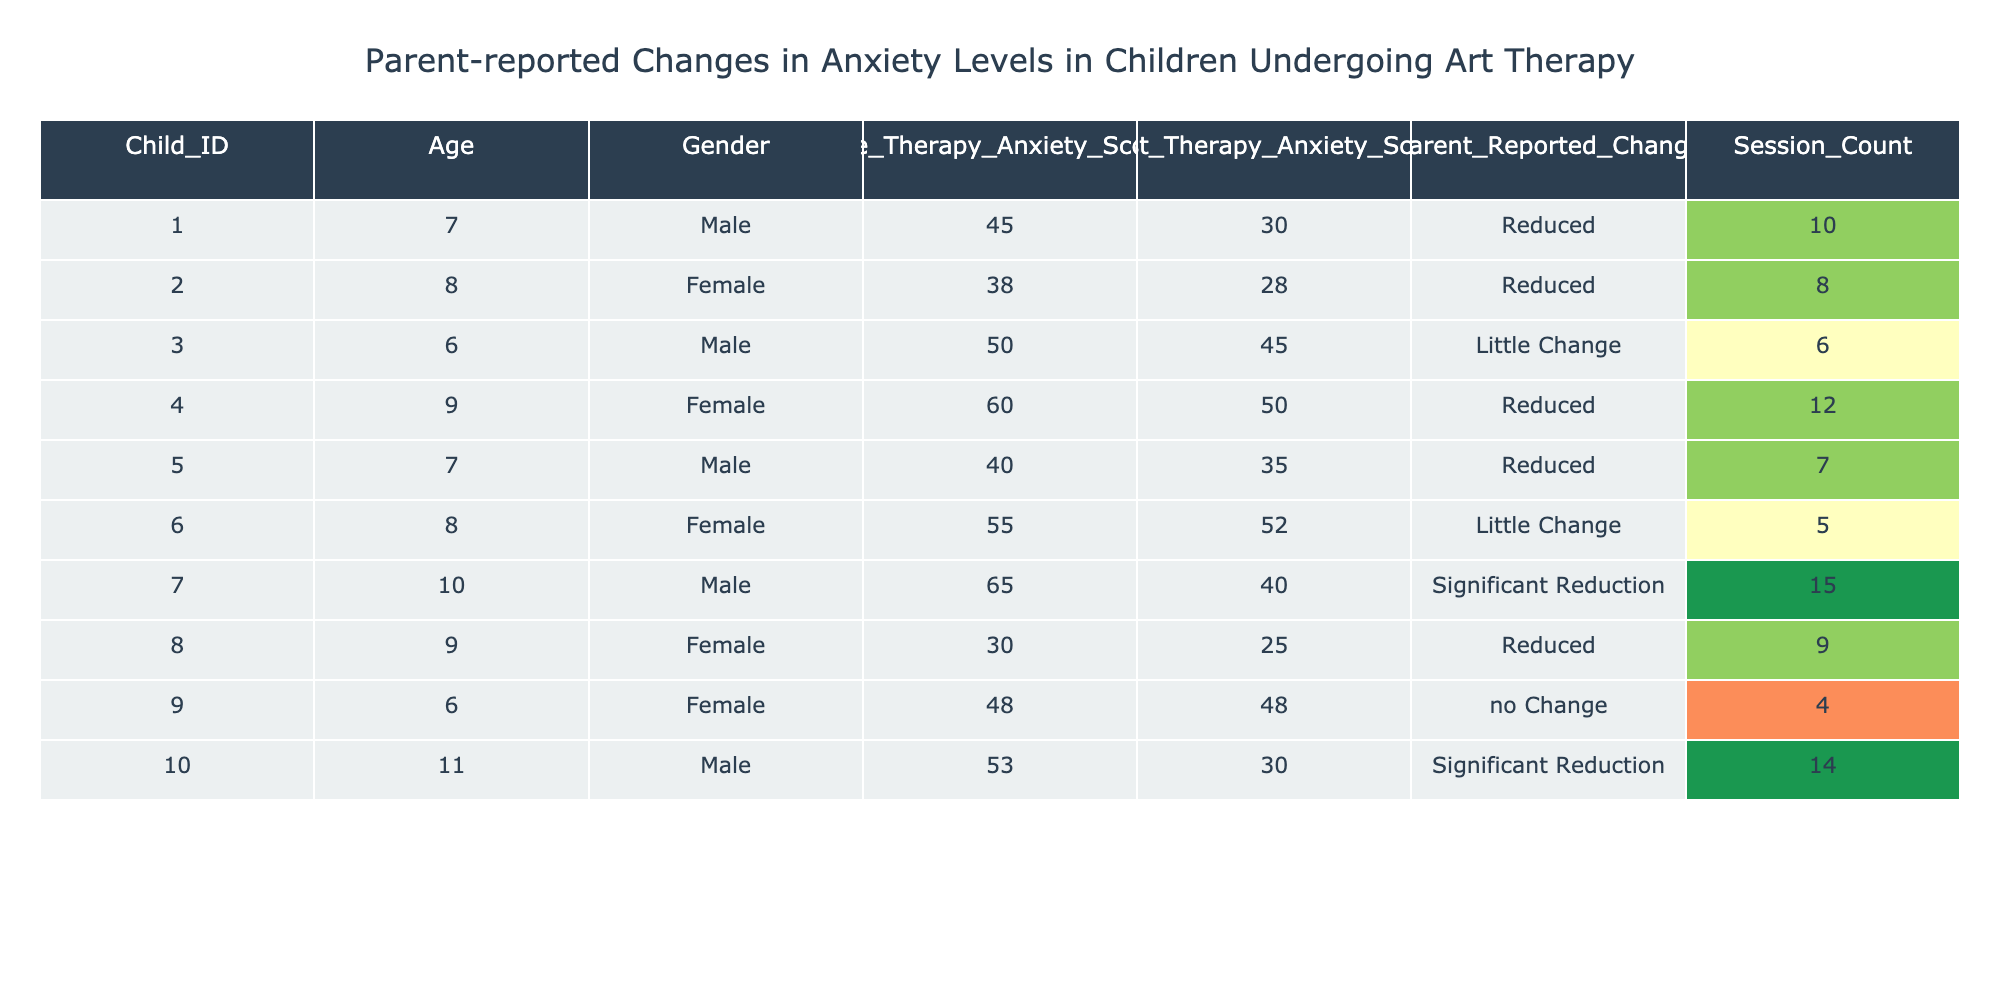What is the Pre-Therapy Anxiety Score of Child ID 007? The table lists the details for Child ID 007, including their Pre-Therapy Anxiety Score, which is specifically mentioned in the corresponding column. The score for Child ID 007 is 65.
Answer: 65 How many children reported "no Change" in their anxiety levels? By examining the column for Parent Reported Change, we see that out of the ten children, only Child ID 009 has reported "no Change."
Answer: 1 What is the average number of therapy sessions attended by children who experienced a "Reduced" anxiety level? We first identify children with a "Reduced" change: Child IDs 001, 002, 004, 005, and 008. Their session counts are 10, 8, 12, 7, and 9, respectively. Adding these gives us 10 + 8 + 12 + 7 + 9 = 46. The average is then calculated by dividing by the number of children (5), which is 46/5 = 9.2.
Answer: 9.2 Did all children who reported "Significant Reduction" in anxiety attend more than 10 sessions? We find the children who reported "Significant Reduction," which are Child IDs 007 and 010. Checking their session counts, Child ID 007 attended 15 sessions, and Child ID 010 attended 14 sessions. Both values are greater than 10, confirming that all did attend more than 10 sessions.
Answer: Yes Which gender reported the most "Significant Reduction" in anxiety levels? Analyzing the data, we find Child ID 007 (Male) and Child ID 010 (Male) reported "Significant Reduction." Hence, the total for males is two. There are no females in this category. Thus, males reported a "Significant Reduction" more than any gender.
Answer: Male What is the difference between the highest and lowest Post-Therapy Anxiety Score in the table? The highest Post-Therapy Anxiety Score can be found for Child ID 006, with a score of 52, while the lowest is for Child ID 009, who scored 48. The difference is calculated by subtracting the lowest from the highest: 52 - 48 = 4.
Answer: 4 How many children are there in total who underwent art therapy? Scanning through the table, we count the rows representing children who underwent therapy. There are 10 entries listed, confirming that there are 10 children in total.
Answer: 10 What percentage of the children reported any level of anxiety reduction? To find the percentage, we identify the children who reported "Significant Reduction," "Reduced," and "Little Change." These are Child IDs 001, 002, 004, 005, 007, 008, and 010 (a total of 7). The percentage is calculated by (7/10) * 100, which equals 70%.
Answer: 70% 